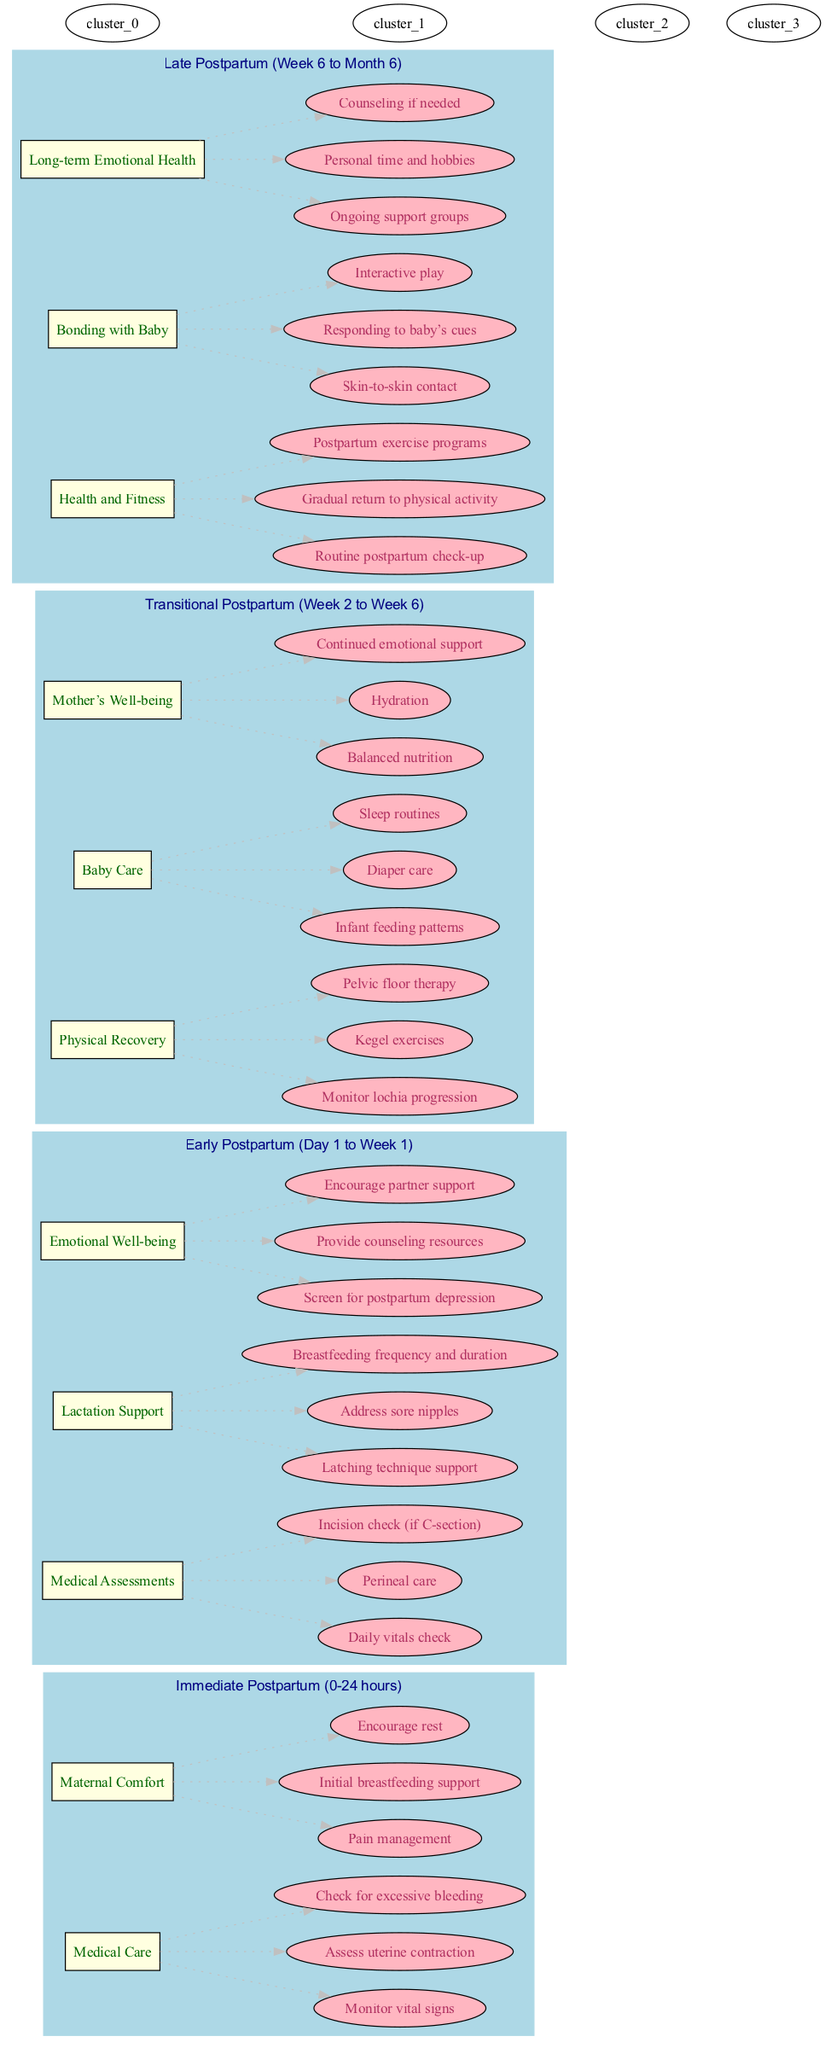What is the first stage of the postpartum timeline? The diagram clearly indicates the first stage listed is "Immediate Postpartum (0-24 hours)."
Answer: Immediate Postpartum (0-24 hours) How many elements are there in the Early Postpartum stage? Upon reviewing the Early Postpartum stage, there are three elements present: Medical Assessments, Lactation Support, and Emotional Well-being.
Answer: 3 Which activity is associated with Maternal Comfort during the Immediate Postpartum stage? In the Immediate Postpartum stage, the activities listed under Maternal Comfort include Pain management, Initial breastfeeding support, and Encourage rest. One of these activities is Pain management.
Answer: Pain management What activities are included in the Mother's Well-being element? The Mother's Well-being element includes activities focused on Balanced nutrition, Hydration, and Continued emotional support. So, all three activities are relevant to this element.
Answer: Balanced nutrition, Hydration, Continued emotional support What is the last activity listed in the Late Postpartum stage? Rechecking the Late Postpartum stage, we find that the last activity under Long-term Emotional Health is "Counseling if needed."
Answer: Counseling if needed Which stage includes both Baby Care and Mother's Well-being elements? The diagram shows that both the Baby Care and Mother's Well-being elements are part of the Transitional Postpartum stage, confirming that this stage encompasses both aspects of care.
Answer: Transitional Postpartum (Week 2 to Week 6) What is the main focus of health and fitness activities in the Late Postpartum stage? Within the Late Postpartum stage, health and fitness activities include Routine postpartum check-up, Gradual return to physical activity, and Postpartum exercise programs, indicating a general focus on recovery and fitness.
Answer: Routine postpartum check-up, Gradual return to physical activity, Postpartum exercise programs How many stages are outlined in the postpartum care timeline? By examining the diagram, it is evident that there are four stages outlined in the postpartum care timeline: Immediate Postpartum, Early Postpartum, Transitional Postpartum, and Late Postpartum.
Answer: 4 What type of exercise activity is suggested during the Transitional Postpartum stage? The diagram lists Kegel exercises, which focus on pelvic floor strength, as one of the activities in the Transitional Postpartum stage under Physical Recovery.
Answer: Kegel exercises 